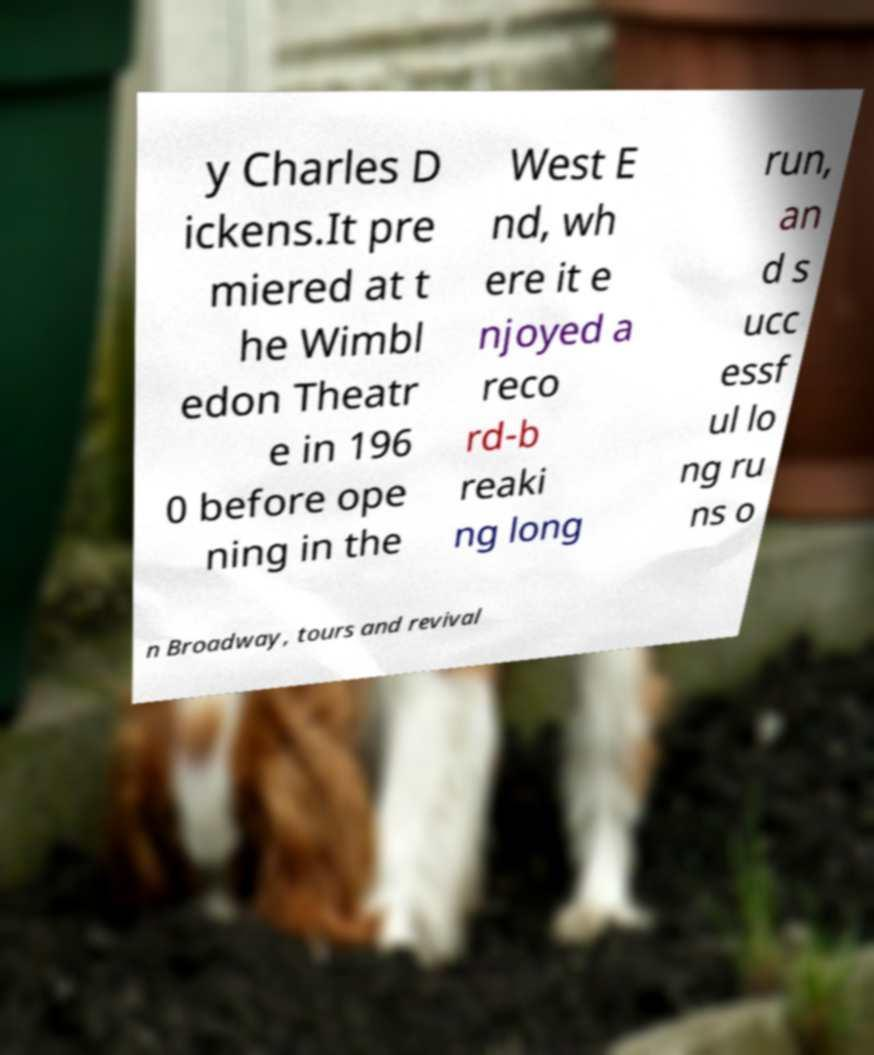There's text embedded in this image that I need extracted. Can you transcribe it verbatim? y Charles D ickens.It pre miered at t he Wimbl edon Theatr e in 196 0 before ope ning in the West E nd, wh ere it e njoyed a reco rd-b reaki ng long run, an d s ucc essf ul lo ng ru ns o n Broadway, tours and revival 